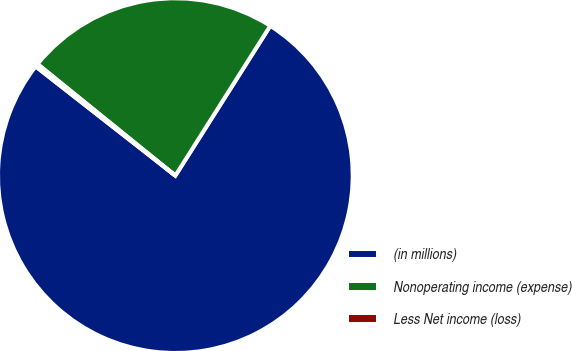<chart> <loc_0><loc_0><loc_500><loc_500><pie_chart><fcel>(in millions)<fcel>Nonoperating income (expense)<fcel>Less Net income (loss)<nl><fcel>76.58%<fcel>23.16%<fcel>0.27%<nl></chart> 